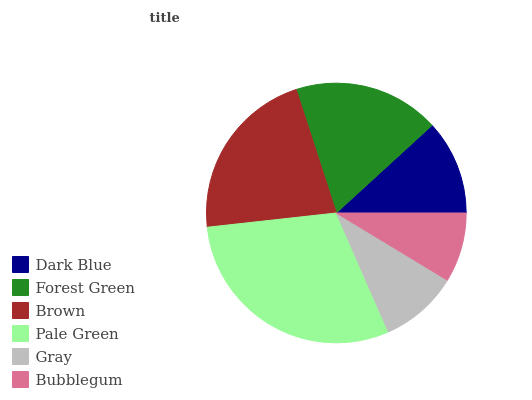Is Bubblegum the minimum?
Answer yes or no. Yes. Is Pale Green the maximum?
Answer yes or no. Yes. Is Forest Green the minimum?
Answer yes or no. No. Is Forest Green the maximum?
Answer yes or no. No. Is Forest Green greater than Dark Blue?
Answer yes or no. Yes. Is Dark Blue less than Forest Green?
Answer yes or no. Yes. Is Dark Blue greater than Forest Green?
Answer yes or no. No. Is Forest Green less than Dark Blue?
Answer yes or no. No. Is Forest Green the high median?
Answer yes or no. Yes. Is Dark Blue the low median?
Answer yes or no. Yes. Is Gray the high median?
Answer yes or no. No. Is Bubblegum the low median?
Answer yes or no. No. 